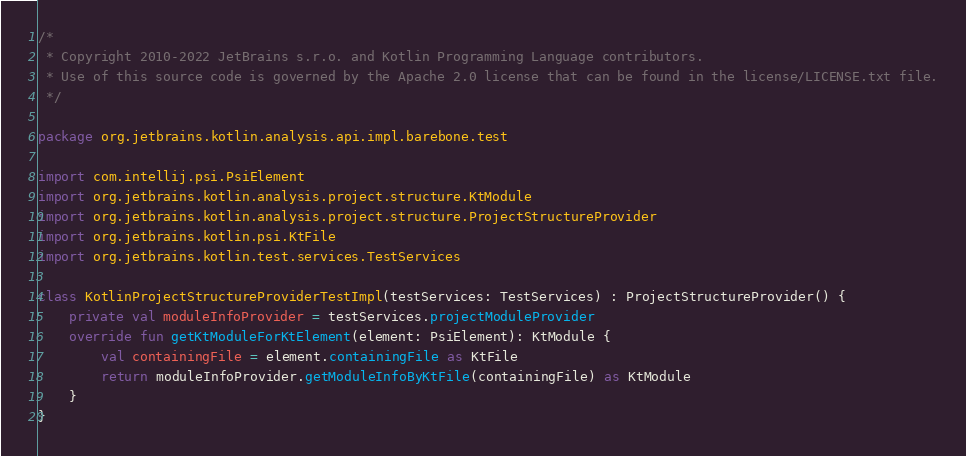<code> <loc_0><loc_0><loc_500><loc_500><_Kotlin_>/*
 * Copyright 2010-2022 JetBrains s.r.o. and Kotlin Programming Language contributors.
 * Use of this source code is governed by the Apache 2.0 license that can be found in the license/LICENSE.txt file.
 */

package org.jetbrains.kotlin.analysis.api.impl.barebone.test

import com.intellij.psi.PsiElement
import org.jetbrains.kotlin.analysis.project.structure.KtModule
import org.jetbrains.kotlin.analysis.project.structure.ProjectStructureProvider
import org.jetbrains.kotlin.psi.KtFile
import org.jetbrains.kotlin.test.services.TestServices

class KotlinProjectStructureProviderTestImpl(testServices: TestServices) : ProjectStructureProvider() {
    private val moduleInfoProvider = testServices.projectModuleProvider
    override fun getKtModuleForKtElement(element: PsiElement): KtModule {
        val containingFile = element.containingFile as KtFile
        return moduleInfoProvider.getModuleInfoByKtFile(containingFile) as KtModule
    }
}
</code> 